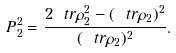Convert formula to latex. <formula><loc_0><loc_0><loc_500><loc_500>P _ { 2 } ^ { 2 } = \frac { 2 \ t r \rho _ { 2 } ^ { 2 } - ( \ t r \rho _ { 2 } ) ^ { 2 } } { ( \ t r \rho _ { 2 } ) ^ { 2 } } .</formula> 